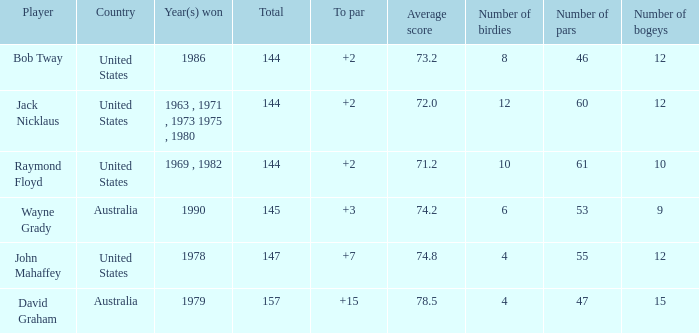What was the average round score of the player who won in 1978? 147.0. 